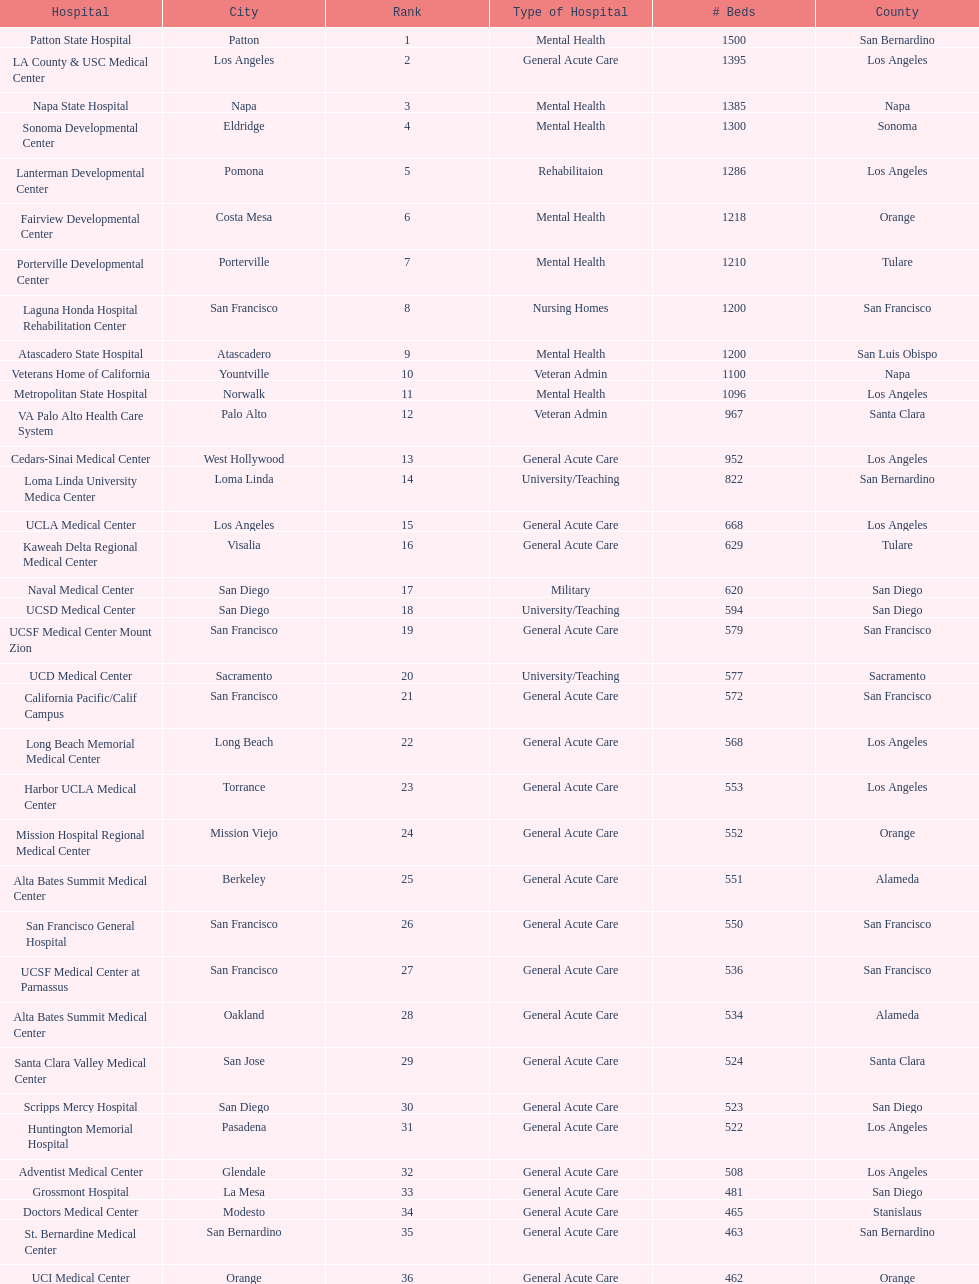How many hospital's have at least 600 beds? 17. 